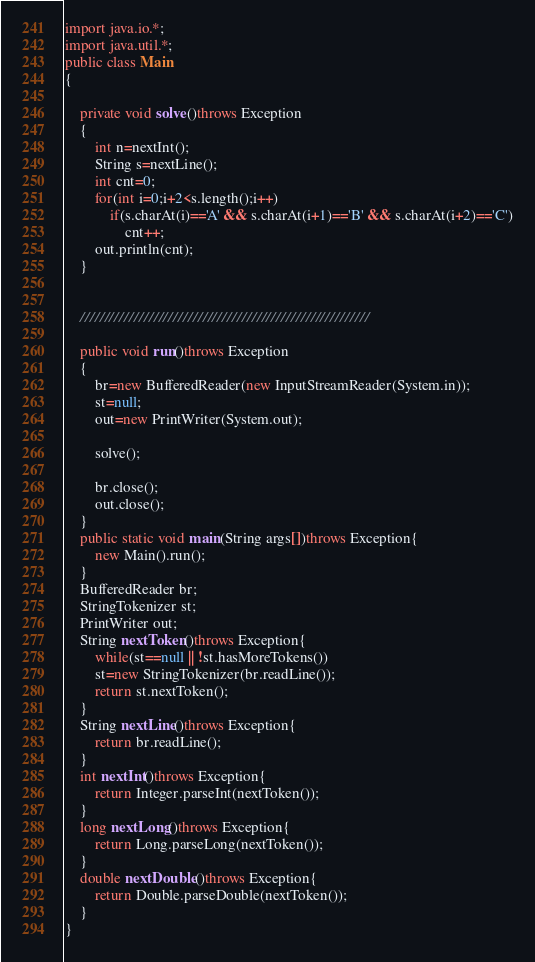<code> <loc_0><loc_0><loc_500><loc_500><_Java_>import java.io.*;
import java.util.*;
public class Main
{
	
	private void solve()throws Exception
	{
		int n=nextInt();
		String s=nextLine();
		int cnt=0;
		for(int i=0;i+2<s.length();i++)
			if(s.charAt(i)=='A' && s.charAt(i+1)=='B' && s.charAt(i+2)=='C')
				cnt++;
		out.println(cnt);
	}

	 
	///////////////////////////////////////////////////////////

	public void run()throws Exception
	{
		br=new BufferedReader(new InputStreamReader(System.in));
		st=null;
		out=new PrintWriter(System.out);

		solve();
		
		br.close();
		out.close();
	}
	public static void main(String args[])throws Exception{
		new Main().run();
	}
	BufferedReader br;
	StringTokenizer st;
	PrintWriter out;
	String nextToken()throws Exception{
		while(st==null || !st.hasMoreTokens())
		st=new StringTokenizer(br.readLine());
		return st.nextToken();
	}
	String nextLine()throws Exception{
		return br.readLine();
	}
	int nextInt()throws Exception{
		return Integer.parseInt(nextToken());
	}
	long nextLong()throws Exception{
		return Long.parseLong(nextToken());
	}
	double nextDouble()throws Exception{
		return Double.parseDouble(nextToken());
	}
}</code> 